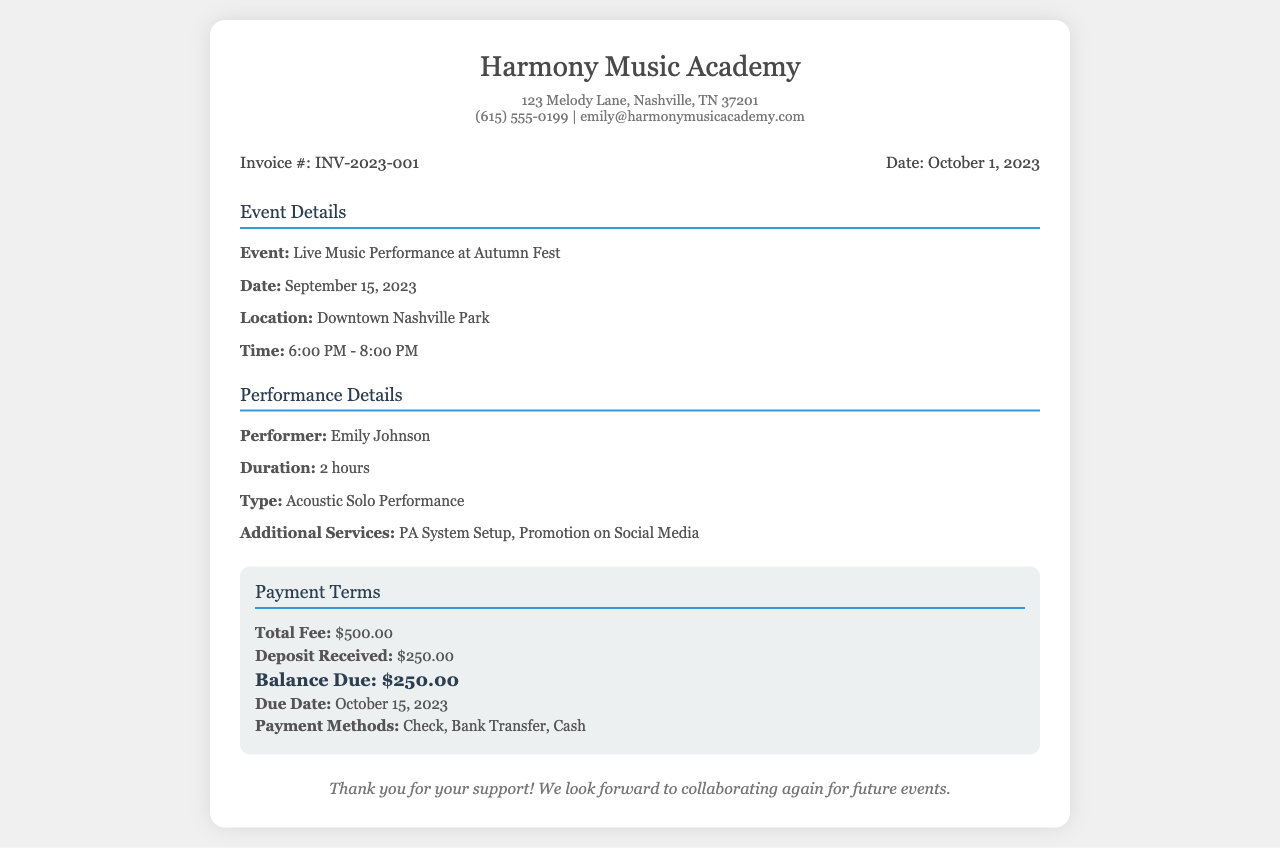What is the invoice number? The invoice number is a unique identifier for the billing document, listed as INV-2023-001.
Answer: INV-2023-001 What is the date of the event? The event date is indicated as the specific day when it took place, on September 15, 2023.
Answer: September 15, 2023 How many hours did the performer perform? The duration of the performance is directly mentioned and stated as 2 hours.
Answer: 2 hours What is the total fee for the performance? The total fee for the performance is outlined clearly in the payment terms as $500.00.
Answer: $500.00 What is the balance due? The balance due is the amount that remains to be paid after the deposit, marked as $250.00.
Answer: $250.00 When is the payment due? The due date for the payment is specified in the document as October 15, 2023.
Answer: October 15, 2023 What type of performance was it? The document specifies the performance type, which is an Acoustic Solo Performance.
Answer: Acoustic Solo Performance What services were additional? Additional services provided during the performance are listed, including PA System Setup and Promotion on Social Media.
Answer: PA System Setup, Promotion on Social Media Who was the performer? The name of the performer mentioned in the document is Emily Johnson.
Answer: Emily Johnson 